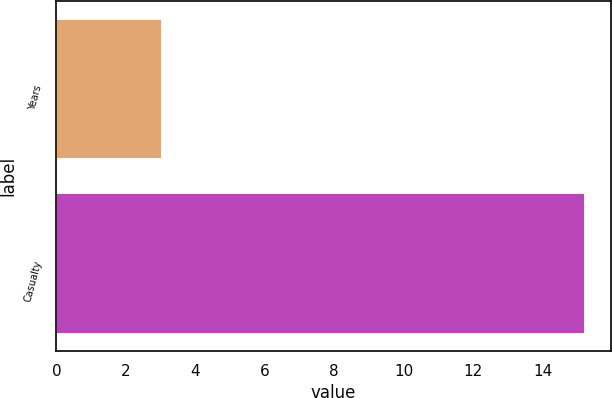Convert chart. <chart><loc_0><loc_0><loc_500><loc_500><bar_chart><fcel>Years<fcel>Casualty<nl><fcel>3<fcel>15.2<nl></chart> 